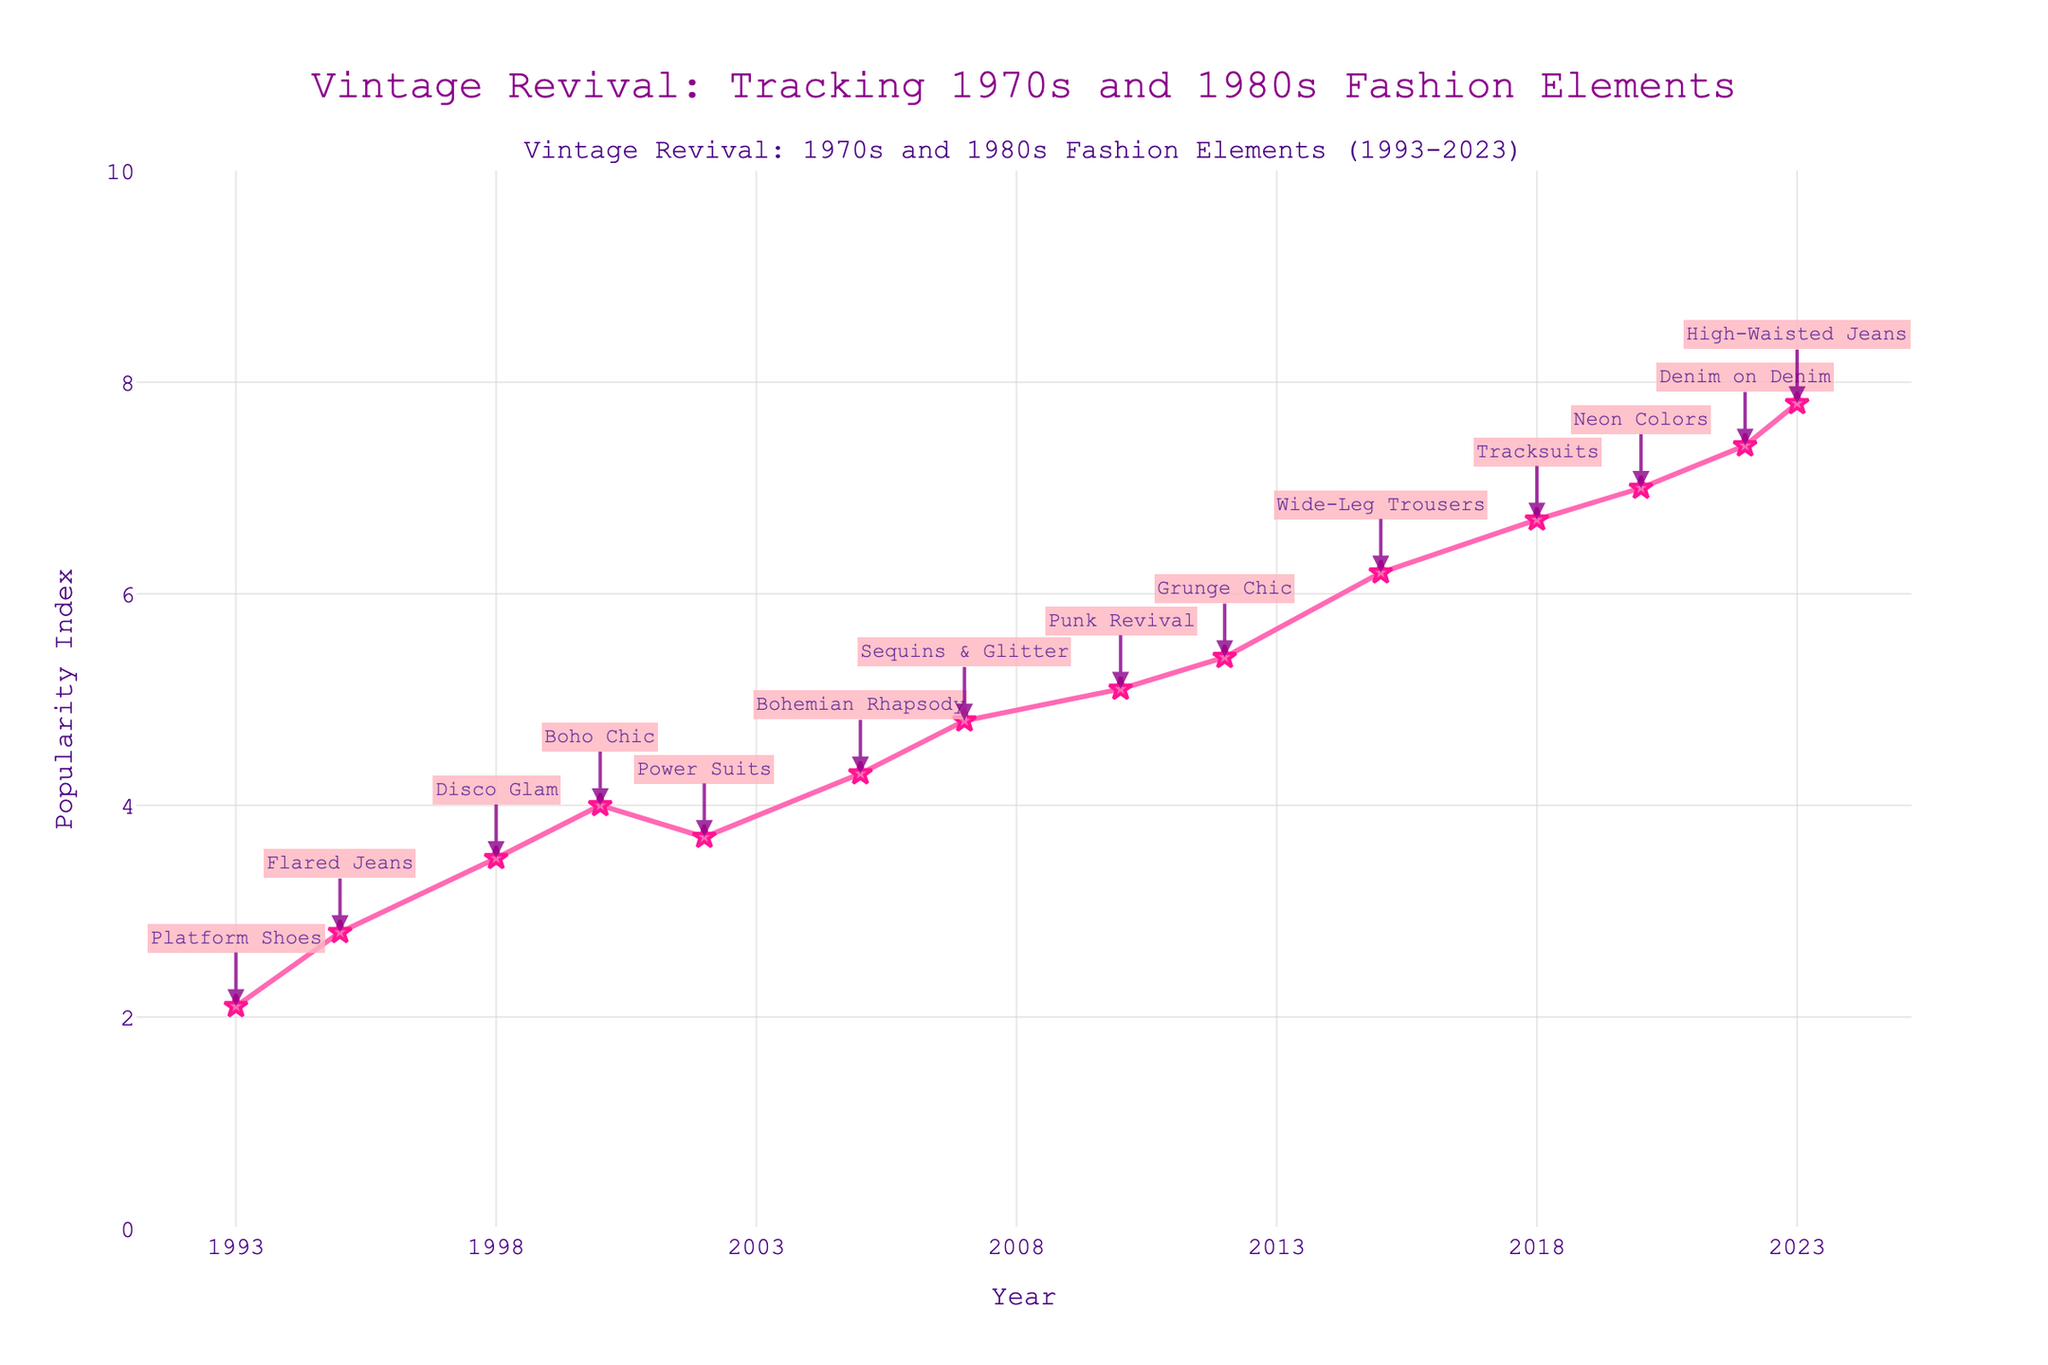What is the title of the plot? Look at the top of the plot where the title is displayed. The title is "Vintage Revival: Tracking 1970s and 1980s Fashion Elements".
Answer: Vintage Revival: Tracking 1970s and 1980s Fashion Elements How many data points are in the plot? Count the number of markers or annotations representing each data point on the plot. Each trend label corresponds to a data point.
Answer: 14 What is the highest value of the Popularity Index and in which year did it occur? Find the highest marker on the y-axis, and note the corresponding year on the x-axis. The highest value of the Popularity Index is 7.8 in 2023.
Answer: 7.8, 2023 Which fashion element has a Popularity Index of 5.1, and in which year did it occur? Look for the annotation with the indicated Popularity Index on the y-axis (5.1) and note the corresponding year on the x-axis. The trend is "Punk Revival," which occurred in 2010.
Answer: Punk Revival, 2010 What is the range of years covered in the plot? Observe the x-axis starting and ending points. The plot ranges from 1993 to 2023.
Answer: 1993 to 2023 How many times does the Popularity Index exceed 6? Count the number of points where the Popularity Index is greater than 6 by looking at the y-axis values. The Popularity Index exceeds 6 three times.
Answer: 3 Between which two consecutive years does the Popularity Index show the largest increase? Compare the Popularity Index values between each pair of consecutive years and identify the largest difference. The largest increase is between 2012 (5.4) and 2015 (6.2).
Answer: 2012 and 2015 Which year corresponded to the introduction of "Tracksuits" and its Popularity Index? Find the annotation for "Tracksuits." It occurs in 2018 with a Popularity Index of 6.7.
Answer: 2018, 6.7 What is the average Popularity Index from the data points provided? Sum all Popularity Index values and divide by the number of data points: (2.1 + 2.8 + 3.5 + 4.0 + 3.7 + 4.3 + 4.8 + 5.1 + 5.4 + 6.2 + 6.7 + 7.0 + 7.4 + 7.8) / 14.
Answer: 5.00 Which trend has a lower Popularity Index: "Bohemian Rhapsody" or "Denim on Denim"? Compare the Popularity Index values for "Bohemian Rhapsody" (2005, 4.3) and "Denim on Denim" (2022, 7.4). "Bohemian Rhapsody" has a lower value.
Answer: Bohemian Rhapsody 